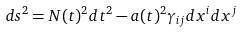Convert formula to latex. <formula><loc_0><loc_0><loc_500><loc_500>d s ^ { 2 } = N ( t ) ^ { 2 } d t ^ { 2 } - a ( t ) ^ { 2 } \gamma _ { i j } d x ^ { i } d x ^ { j }</formula> 